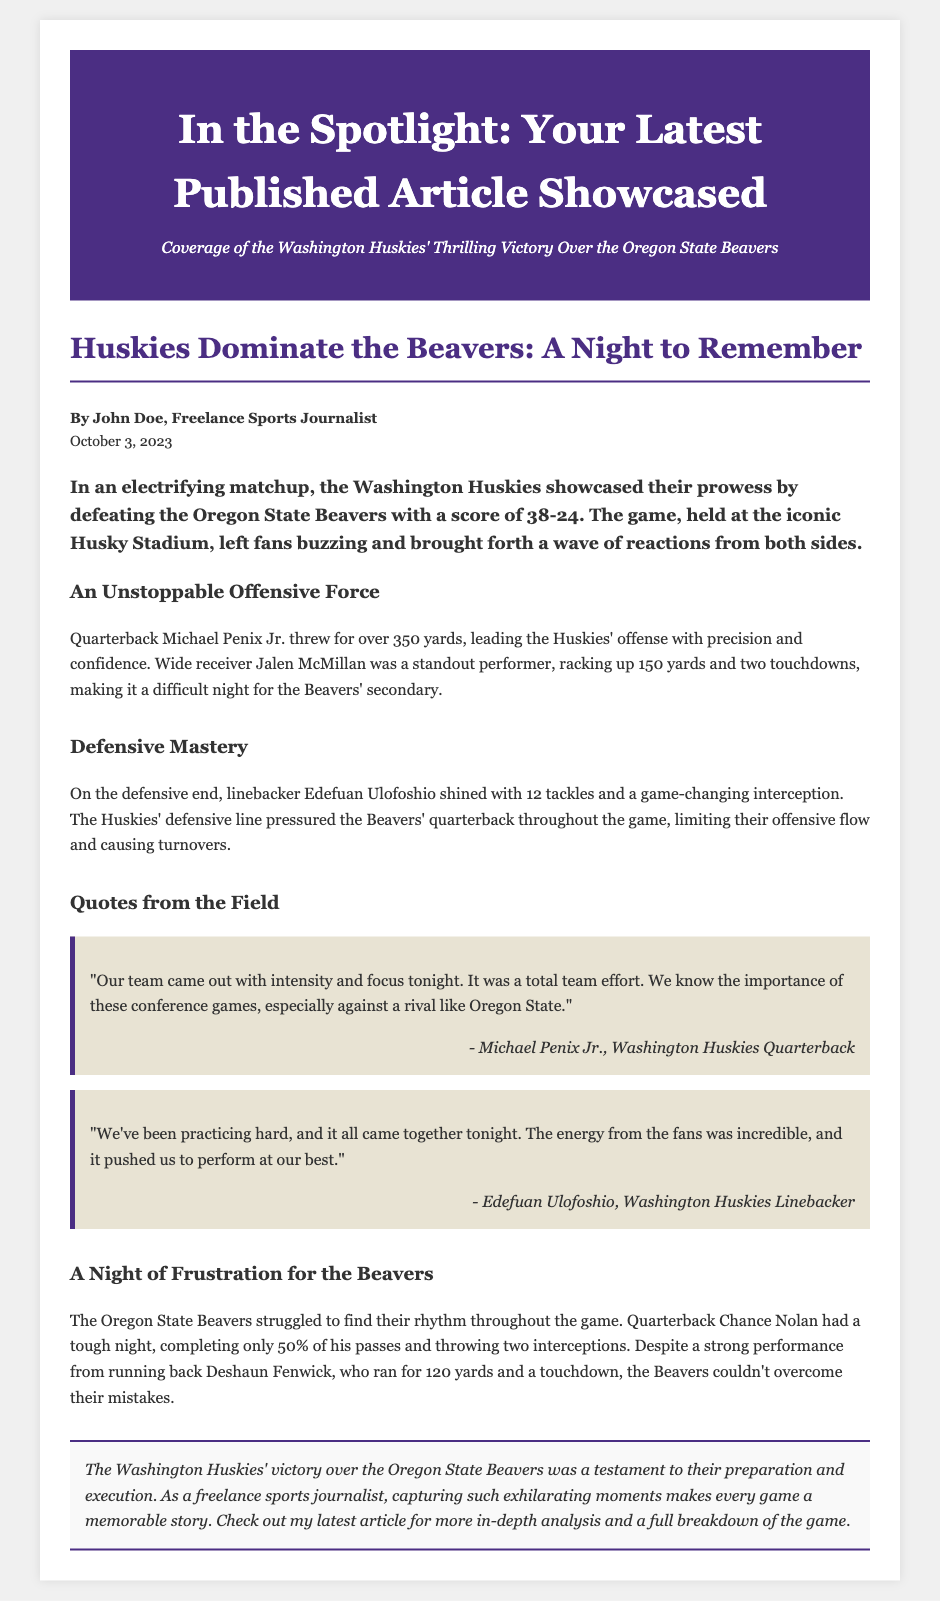What is the title of the article? The title of the article is presented prominently in the header of the document.
Answer: In the Spotlight: Your Latest Published Article Showcased Who is the author of the article? The author of the article is mentioned in the author-date section.
Answer: John Doe What was the date of publication? The publication date is found in the author-date section of the document.
Answer: October 3, 2023 What was the final score of the game? The final score, detailing the outcome of the matchup, is provided in the introduction.
Answer: 38-24 Which player threw for over 350 yards? The document specifically mentions this player's achievement in the offensive section.
Answer: Michael Penix Jr How many tackles did Edefuan Ulofoshio make? This statistic is detailed in the defensive mastery section.
Answer: 12 What was a major issue for the Beavers, according to the article? The troubles faced by the Beavers are highlighted in the section discussing their performance.
Answer: Two interceptions What type of article is this? The format and content of the document indicate it is showcasing a specific event and analysis.
Answer: Newspaper layout What was emphasized about the Huskies' victory? The conclusion summarizes the key aspect of the victory in a concise manner.
Answer: Preparation and execution 